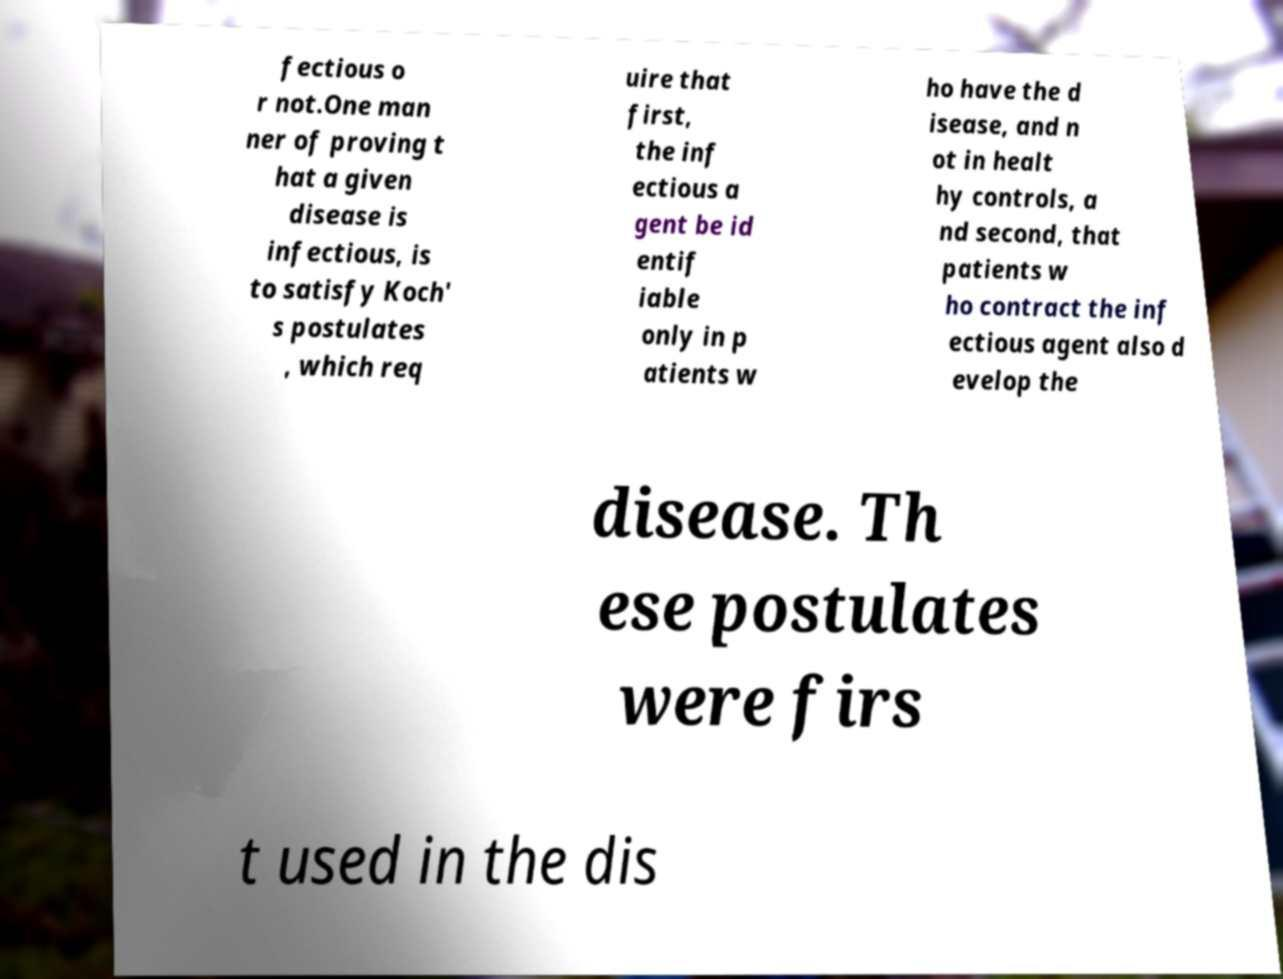Please read and relay the text visible in this image. What does it say? fectious o r not.One man ner of proving t hat a given disease is infectious, is to satisfy Koch' s postulates , which req uire that first, the inf ectious a gent be id entif iable only in p atients w ho have the d isease, and n ot in healt hy controls, a nd second, that patients w ho contract the inf ectious agent also d evelop the disease. Th ese postulates were firs t used in the dis 